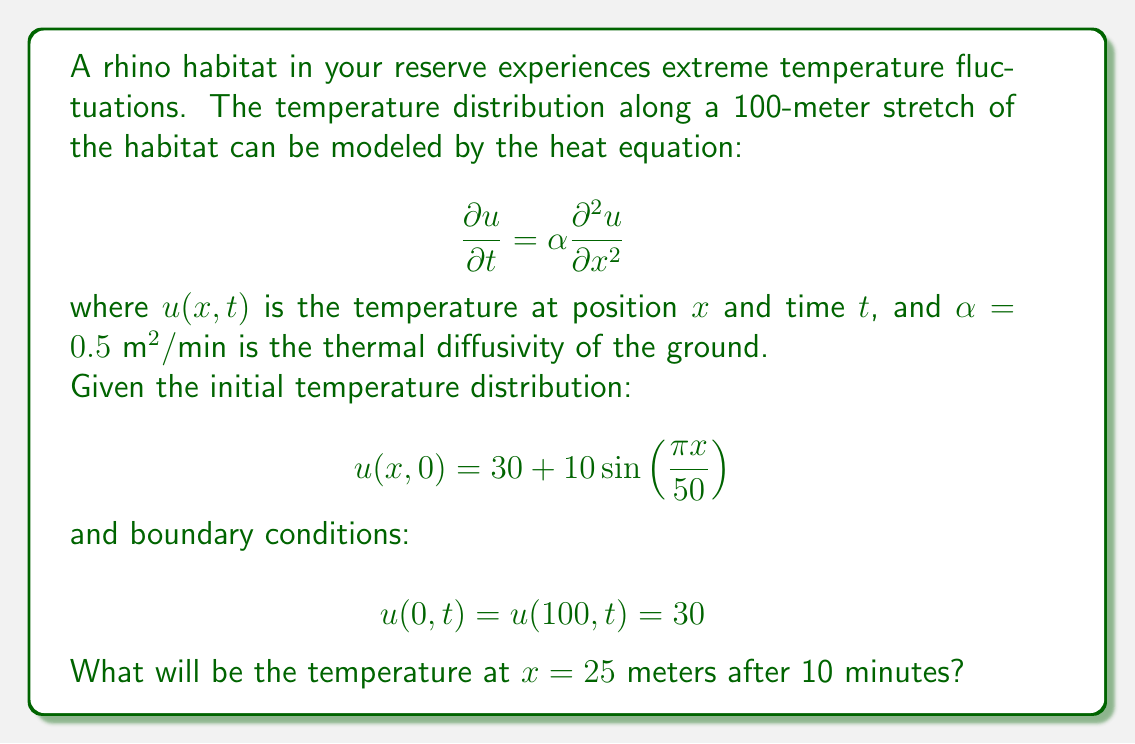Could you help me with this problem? To solve this problem, we need to use the separation of variables method for the heat equation.

Step 1: Separate the solution into spatial and temporal parts.
Let $u(x,t) = X(x)T(t)$

Step 2: Substitute into the heat equation and separate variables.
$$\frac{T'(t)}{T(t)} = \alpha \frac{X''(x)}{X(x)} = -\lambda$$
where $\lambda$ is a constant.

Step 3: Solve the spatial equation.
$$X''(x) + \frac{\lambda}{\alpha}X(x) = 0$$
With boundary conditions $X(0) = X(100) = 0$, we get the eigenvalues and eigenfunctions:
$$\lambda_n = \frac{n^2\pi^2\alpha}{10000}, \quad X_n(x) = \sin\left(\frac{n\pi x}{100}\right), \quad n = 1,2,3,\ldots$$

Step 4: Solve the temporal equation.
$$T_n(t) = e^{-\lambda_n t}$$

Step 5: The general solution is:
$$u(x,t) = 30 + \sum_{n=1}^{\infty} b_n \sin\left(\frac{n\pi x}{100}\right)e^{-\frac{n^2\pi^2\alpha t}{10000}}$$

Step 6: Find $b_n$ using the initial condition.
$$10\sin\left(\frac{\pi x}{50}\right) = \sum_{n=1}^{\infty} b_n \sin\left(\frac{n\pi x}{100}\right)$$

Only $n=2$ contributes, so $b_2 = 10$ and all other $b_n = 0$.

Step 7: The final solution is:
$$u(x,t) = 30 + 10\sin\left(\frac{\pi x}{50}\right)e^{-\frac{\pi^2\alpha t}{2500}}$$

Step 8: Evaluate at $x = 25$ and $t = 10$:
$$u(25,10) = 30 + 10\sin\left(\frac{\pi \cdot 25}{50}\right)e^{-\frac{\pi^2 \cdot 0.5 \cdot 10}{2500}}$$
$$= 30 + 10 \cdot 1 \cdot e^{-0.0197}$$
$$\approx 39.80$$
Answer: 39.80°C 